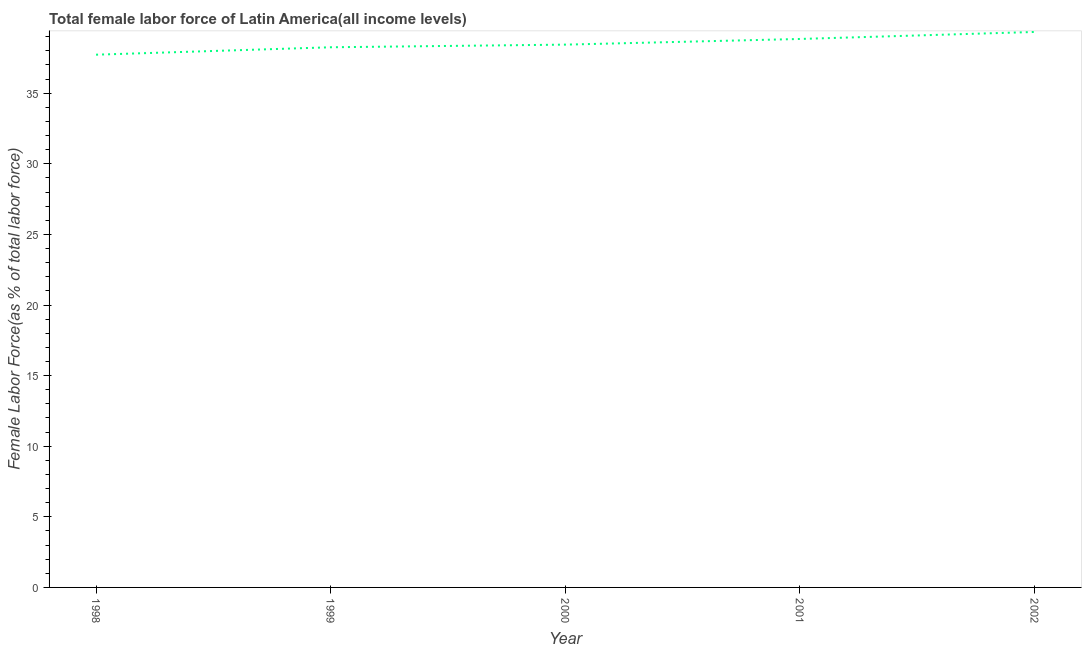What is the total female labor force in 1999?
Your response must be concise. 38.25. Across all years, what is the maximum total female labor force?
Provide a short and direct response. 39.34. Across all years, what is the minimum total female labor force?
Your response must be concise. 37.73. In which year was the total female labor force maximum?
Ensure brevity in your answer.  2002. In which year was the total female labor force minimum?
Keep it short and to the point. 1998. What is the sum of the total female labor force?
Provide a short and direct response. 192.61. What is the difference between the total female labor force in 2001 and 2002?
Offer a very short reply. -0.5. What is the average total female labor force per year?
Give a very brief answer. 38.52. What is the median total female labor force?
Offer a very short reply. 38.44. In how many years, is the total female labor force greater than 35 %?
Keep it short and to the point. 5. Do a majority of the years between 2001 and 2002 (inclusive) have total female labor force greater than 36 %?
Your answer should be compact. Yes. What is the ratio of the total female labor force in 1998 to that in 2002?
Provide a short and direct response. 0.96. Is the total female labor force in 1998 less than that in 2001?
Your response must be concise. Yes. Is the difference between the total female labor force in 2000 and 2002 greater than the difference between any two years?
Give a very brief answer. No. What is the difference between the highest and the second highest total female labor force?
Provide a short and direct response. 0.5. What is the difference between the highest and the lowest total female labor force?
Ensure brevity in your answer.  1.61. In how many years, is the total female labor force greater than the average total female labor force taken over all years?
Provide a short and direct response. 2. Does the total female labor force monotonically increase over the years?
Your answer should be compact. Yes. How many lines are there?
Your response must be concise. 1. How many years are there in the graph?
Give a very brief answer. 5. What is the difference between two consecutive major ticks on the Y-axis?
Offer a terse response. 5. Does the graph contain grids?
Offer a terse response. No. What is the title of the graph?
Your answer should be very brief. Total female labor force of Latin America(all income levels). What is the label or title of the Y-axis?
Give a very brief answer. Female Labor Force(as % of total labor force). What is the Female Labor Force(as % of total labor force) of 1998?
Keep it short and to the point. 37.73. What is the Female Labor Force(as % of total labor force) in 1999?
Make the answer very short. 38.25. What is the Female Labor Force(as % of total labor force) in 2000?
Make the answer very short. 38.44. What is the Female Labor Force(as % of total labor force) of 2001?
Your answer should be compact. 38.84. What is the Female Labor Force(as % of total labor force) in 2002?
Your response must be concise. 39.34. What is the difference between the Female Labor Force(as % of total labor force) in 1998 and 1999?
Ensure brevity in your answer.  -0.53. What is the difference between the Female Labor Force(as % of total labor force) in 1998 and 2000?
Your answer should be very brief. -0.71. What is the difference between the Female Labor Force(as % of total labor force) in 1998 and 2001?
Provide a succinct answer. -1.11. What is the difference between the Female Labor Force(as % of total labor force) in 1998 and 2002?
Give a very brief answer. -1.61. What is the difference between the Female Labor Force(as % of total labor force) in 1999 and 2000?
Give a very brief answer. -0.19. What is the difference between the Female Labor Force(as % of total labor force) in 1999 and 2001?
Offer a terse response. -0.59. What is the difference between the Female Labor Force(as % of total labor force) in 1999 and 2002?
Your response must be concise. -1.08. What is the difference between the Female Labor Force(as % of total labor force) in 2000 and 2001?
Give a very brief answer. -0.4. What is the difference between the Female Labor Force(as % of total labor force) in 2000 and 2002?
Provide a short and direct response. -0.9. What is the difference between the Female Labor Force(as % of total labor force) in 2001 and 2002?
Provide a succinct answer. -0.5. What is the ratio of the Female Labor Force(as % of total labor force) in 1998 to that in 2000?
Offer a very short reply. 0.98. What is the ratio of the Female Labor Force(as % of total labor force) in 1998 to that in 2001?
Ensure brevity in your answer.  0.97. What is the ratio of the Female Labor Force(as % of total labor force) in 1999 to that in 2000?
Make the answer very short. 0.99. What is the ratio of the Female Labor Force(as % of total labor force) in 1999 to that in 2001?
Offer a very short reply. 0.98. What is the ratio of the Female Labor Force(as % of total labor force) in 2000 to that in 2001?
Offer a very short reply. 0.99. What is the ratio of the Female Labor Force(as % of total labor force) in 2001 to that in 2002?
Give a very brief answer. 0.99. 